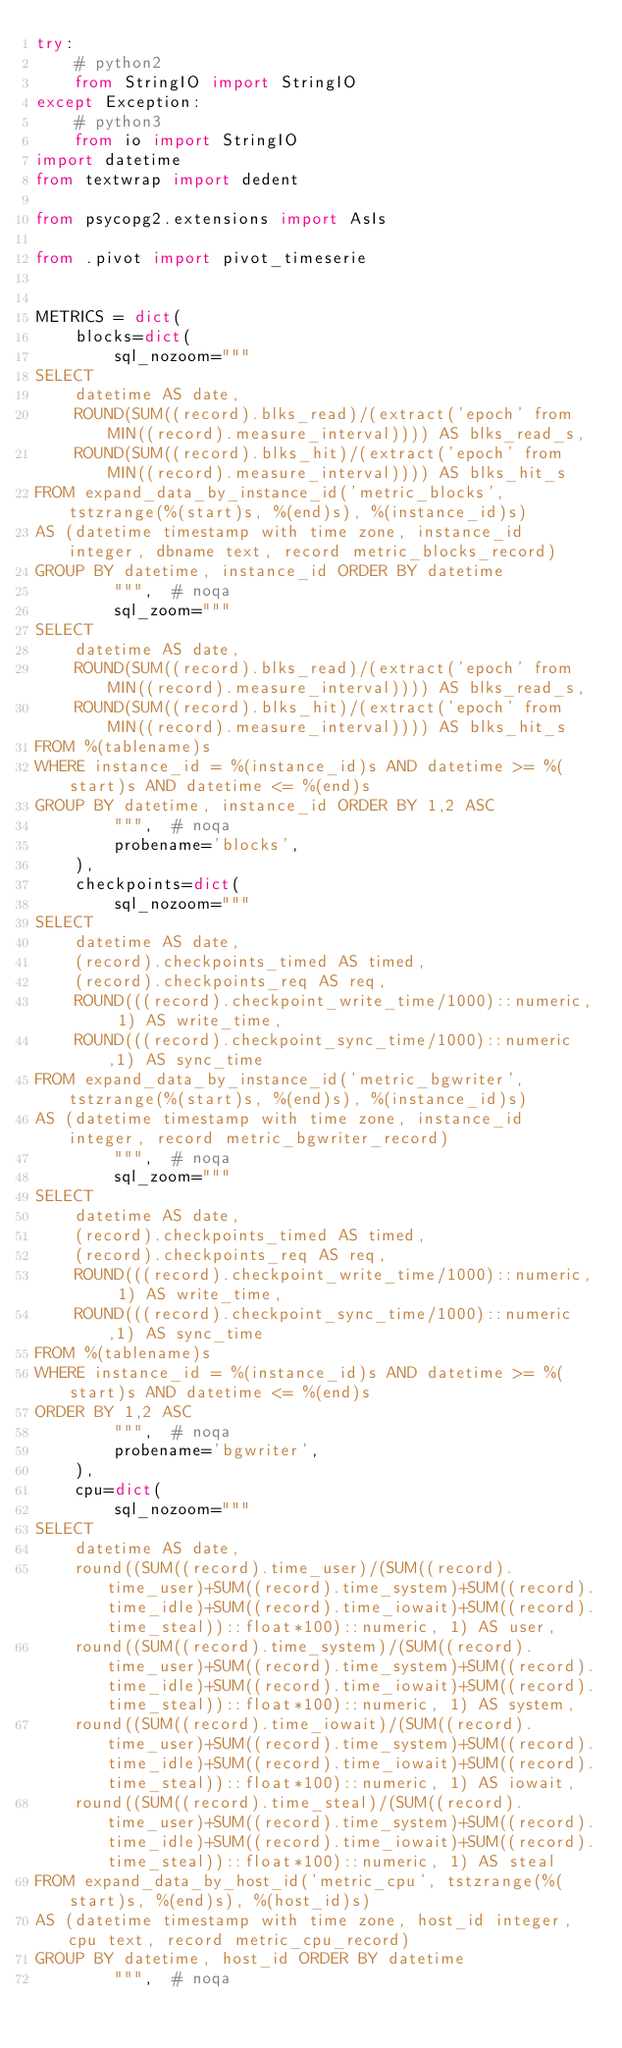<code> <loc_0><loc_0><loc_500><loc_500><_Python_>try:
    # python2
    from StringIO import StringIO
except Exception:
    # python3
    from io import StringIO
import datetime
from textwrap import dedent

from psycopg2.extensions import AsIs

from .pivot import pivot_timeserie


METRICS = dict(
    blocks=dict(
        sql_nozoom="""
SELECT
    datetime AS date,
    ROUND(SUM((record).blks_read)/(extract('epoch' from MIN((record).measure_interval)))) AS blks_read_s,
    ROUND(SUM((record).blks_hit)/(extract('epoch' from MIN((record).measure_interval)))) AS blks_hit_s
FROM expand_data_by_instance_id('metric_blocks', tstzrange(%(start)s, %(end)s), %(instance_id)s)
AS (datetime timestamp with time zone, instance_id integer, dbname text, record metric_blocks_record)
GROUP BY datetime, instance_id ORDER BY datetime
        """,  # noqa
        sql_zoom="""
SELECT
    datetime AS date,
    ROUND(SUM((record).blks_read)/(extract('epoch' from MIN((record).measure_interval)))) AS blks_read_s,
    ROUND(SUM((record).blks_hit)/(extract('epoch' from MIN((record).measure_interval)))) AS blks_hit_s
FROM %(tablename)s
WHERE instance_id = %(instance_id)s AND datetime >= %(start)s AND datetime <= %(end)s
GROUP BY datetime, instance_id ORDER BY 1,2 ASC
        """,  # noqa
        probename='blocks',
    ),
    checkpoints=dict(
        sql_nozoom="""
SELECT
    datetime AS date,
    (record).checkpoints_timed AS timed,
    (record).checkpoints_req AS req,
    ROUND(((record).checkpoint_write_time/1000)::numeric, 1) AS write_time,
    ROUND(((record).checkpoint_sync_time/1000)::numeric,1) AS sync_time
FROM expand_data_by_instance_id('metric_bgwriter', tstzrange(%(start)s, %(end)s), %(instance_id)s)
AS (datetime timestamp with time zone, instance_id integer, record metric_bgwriter_record)
        """,  # noqa
        sql_zoom="""
SELECT
    datetime AS date,
    (record).checkpoints_timed AS timed,
    (record).checkpoints_req AS req,
    ROUND(((record).checkpoint_write_time/1000)::numeric, 1) AS write_time,
    ROUND(((record).checkpoint_sync_time/1000)::numeric,1) AS sync_time
FROM %(tablename)s
WHERE instance_id = %(instance_id)s AND datetime >= %(start)s AND datetime <= %(end)s
ORDER BY 1,2 ASC
        """,  # noqa
        probename='bgwriter',
    ),
    cpu=dict(
        sql_nozoom="""
SELECT
    datetime AS date,
    round((SUM((record).time_user)/(SUM((record).time_user)+SUM((record).time_system)+SUM((record).time_idle)+SUM((record).time_iowait)+SUM((record).time_steal))::float*100)::numeric, 1) AS user,
    round((SUM((record).time_system)/(SUM((record).time_user)+SUM((record).time_system)+SUM((record).time_idle)+SUM((record).time_iowait)+SUM((record).time_steal))::float*100)::numeric, 1) AS system,
    round((SUM((record).time_iowait)/(SUM((record).time_user)+SUM((record).time_system)+SUM((record).time_idle)+SUM((record).time_iowait)+SUM((record).time_steal))::float*100)::numeric, 1) AS iowait,
    round((SUM((record).time_steal)/(SUM((record).time_user)+SUM((record).time_system)+SUM((record).time_idle)+SUM((record).time_iowait)+SUM((record).time_steal))::float*100)::numeric, 1) AS steal
FROM expand_data_by_host_id('metric_cpu', tstzrange(%(start)s, %(end)s), %(host_id)s)
AS (datetime timestamp with time zone, host_id integer, cpu text, record metric_cpu_record)
GROUP BY datetime, host_id ORDER BY datetime
        """,  # noqa</code> 